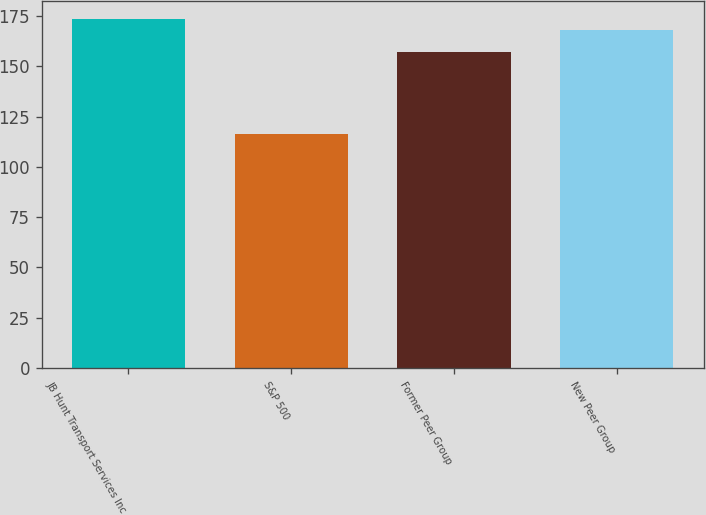Convert chart to OTSL. <chart><loc_0><loc_0><loc_500><loc_500><bar_chart><fcel>JB Hunt Transport Services Inc<fcel>S&P 500<fcel>Former Peer Group<fcel>New Peer Group<nl><fcel>173.61<fcel>116.33<fcel>157.12<fcel>168.24<nl></chart> 